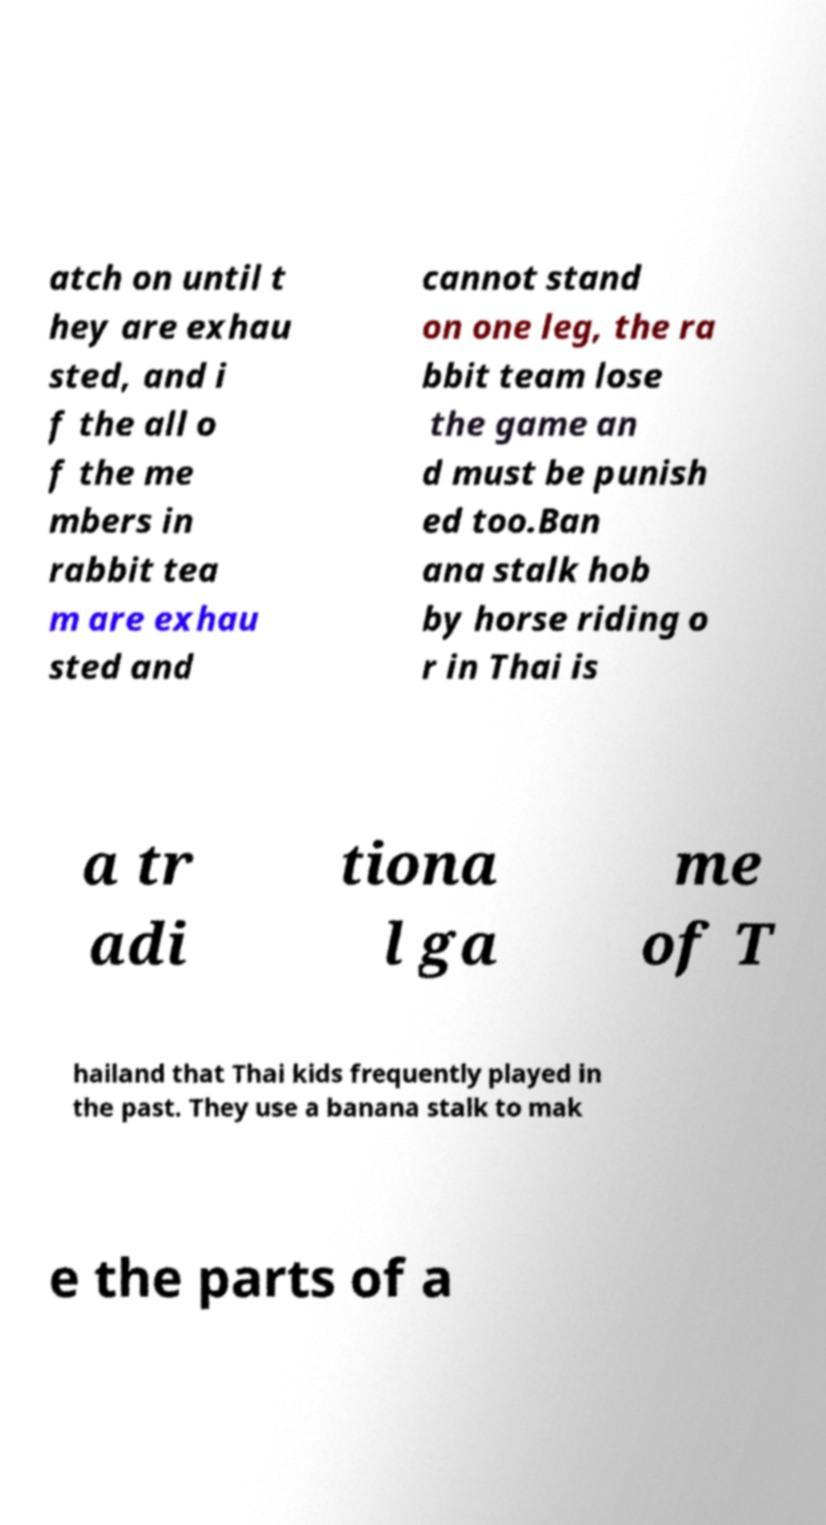Please read and relay the text visible in this image. What does it say? atch on until t hey are exhau sted, and i f the all o f the me mbers in rabbit tea m are exhau sted and cannot stand on one leg, the ra bbit team lose the game an d must be punish ed too.Ban ana stalk hob by horse riding o r in Thai is a tr adi tiona l ga me of T hailand that Thai kids frequently played in the past. They use a banana stalk to mak e the parts of a 